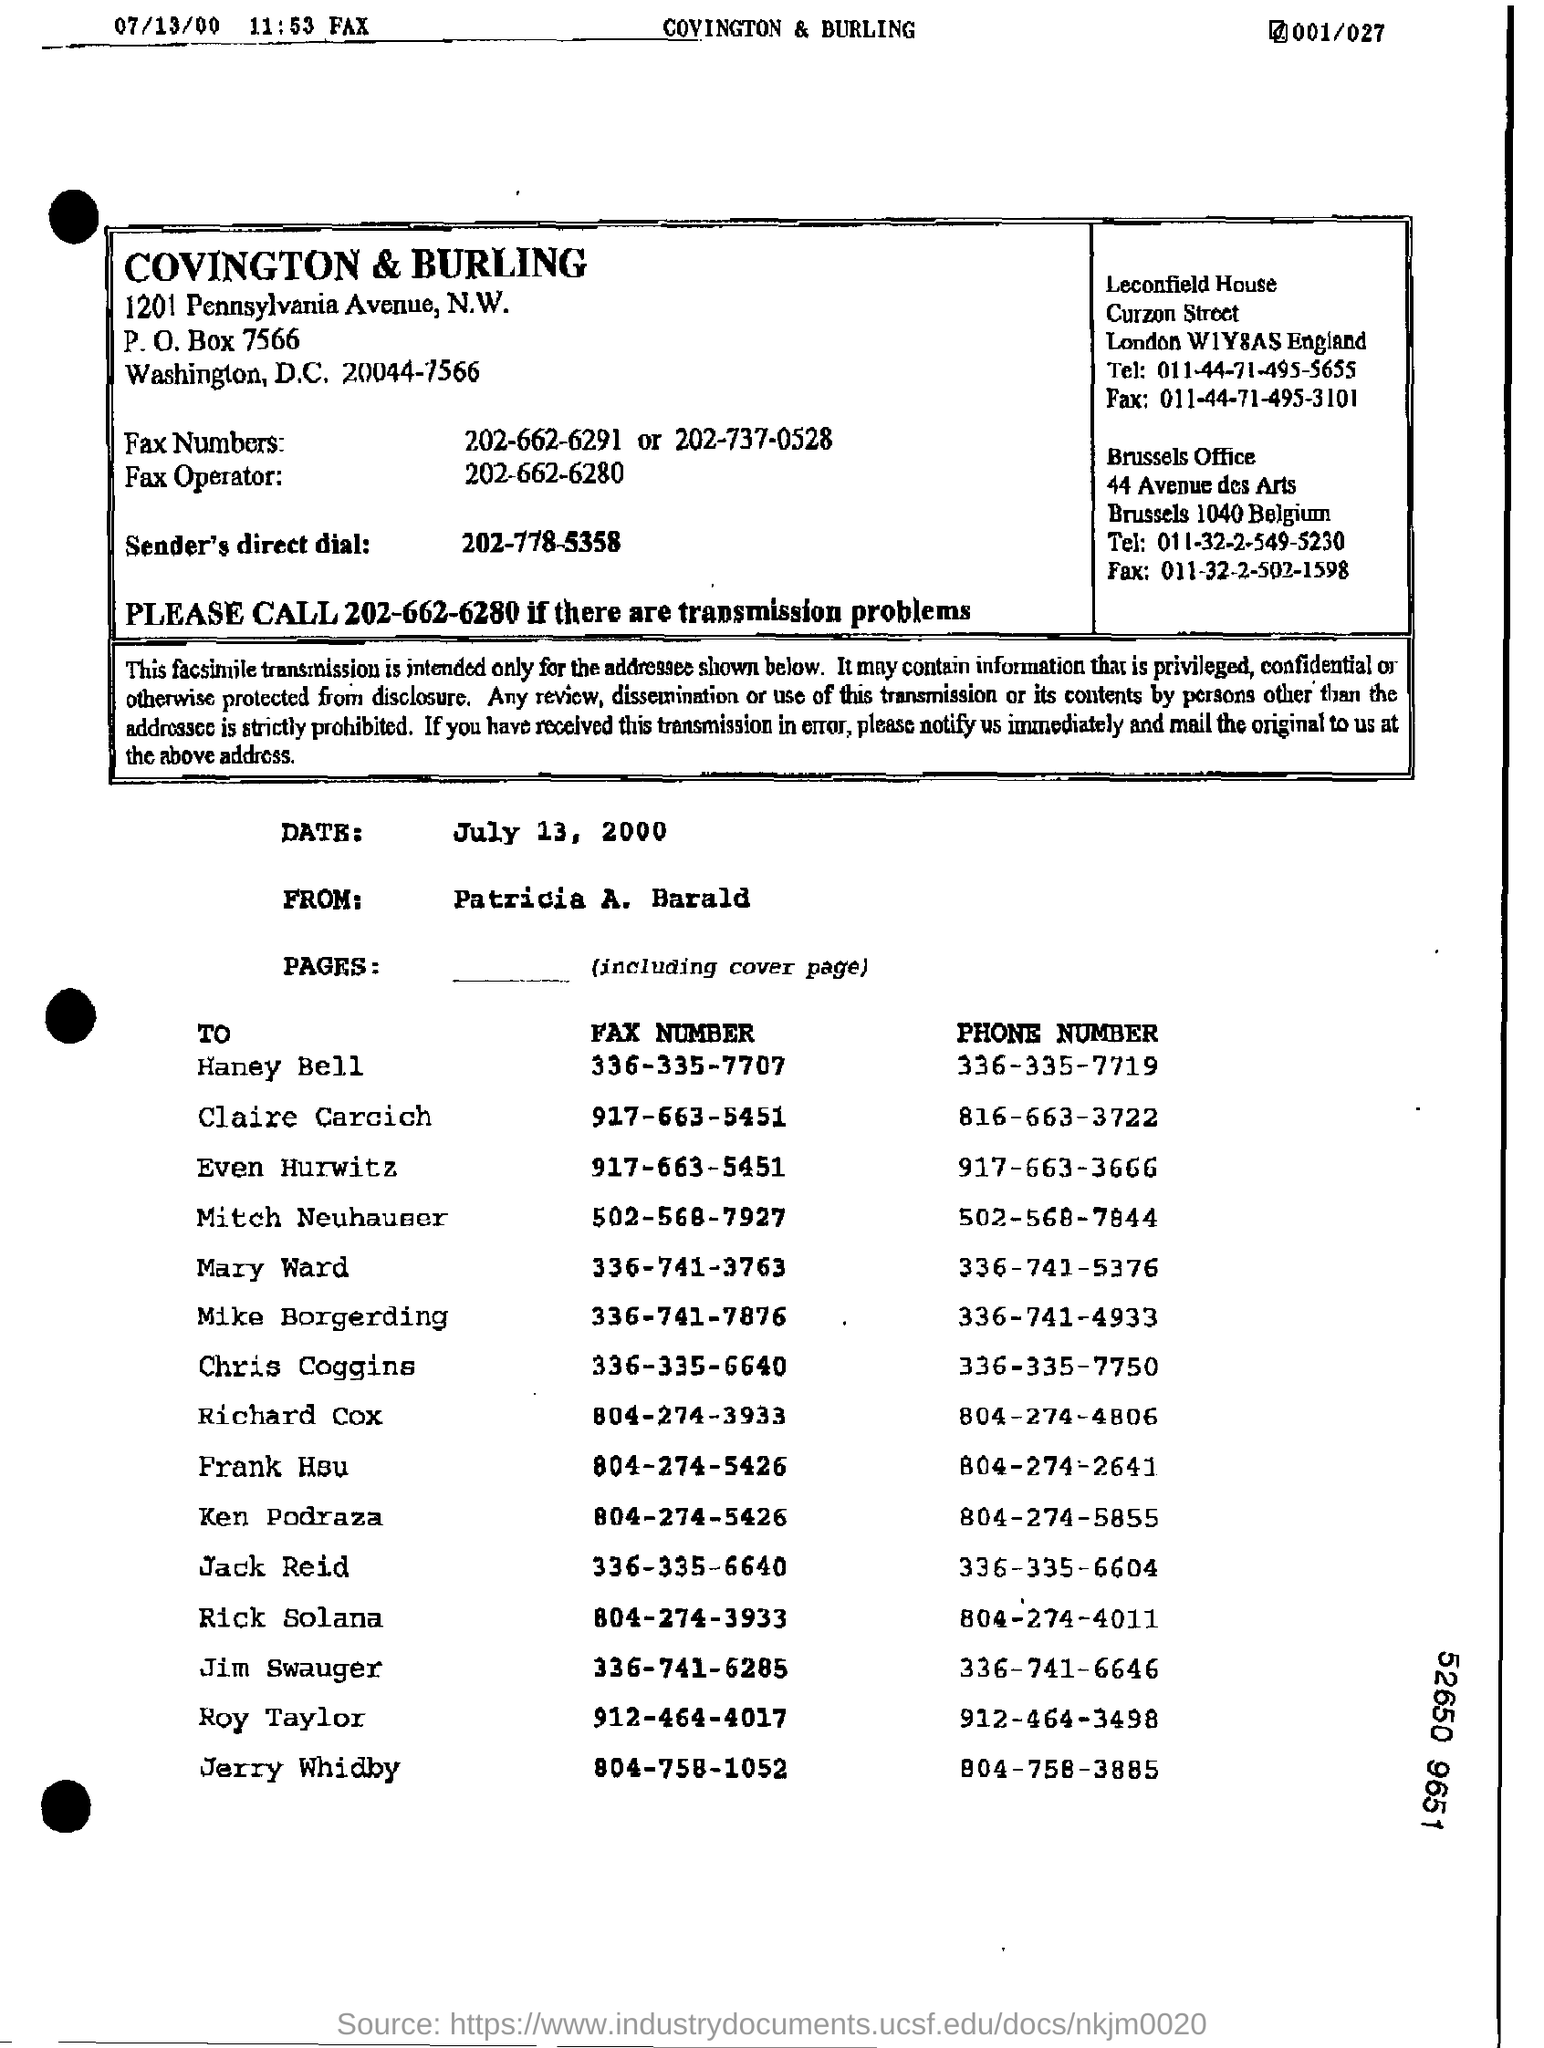What is the heading in the box?
Offer a terse response. COVINGTON & BURLING. What is the date mentioned below the box?
Offer a very short reply. July 13, 2000. Whose FAX NUMBER is 336-335-7707?
Provide a short and direct response. Haney Bell. Whose PHONE NUMBER is the last on the list?
Offer a terse response. Jerry Whidby. 